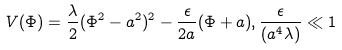Convert formula to latex. <formula><loc_0><loc_0><loc_500><loc_500>V ( \Phi ) = \frac { \lambda } { 2 } ( \Phi ^ { 2 } - a ^ { 2 } ) ^ { 2 } - \frac { \epsilon } { 2 a } ( \Phi + a ) , \frac { \epsilon } { ( a ^ { 4 } \lambda ) } \ll 1</formula> 